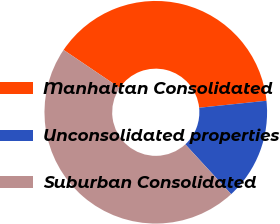Convert chart. <chart><loc_0><loc_0><loc_500><loc_500><pie_chart><fcel>Manhattan Consolidated<fcel>Unconsolidated properties<fcel>Suburban Consolidated<nl><fcel>38.89%<fcel>14.81%<fcel>46.3%<nl></chart> 